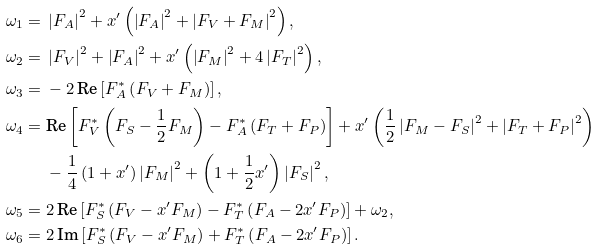Convert formula to latex. <formula><loc_0><loc_0><loc_500><loc_500>\omega _ { 1 } = & \ \left | F _ { A } \right | ^ { 2 } + x ^ { \prime } \left ( \left | F _ { A } \right | ^ { 2 } + \left | F _ { V } + F _ { M } \right | ^ { 2 } \right ) , \\ \omega _ { 2 } = & \ \left | F _ { V } \right | ^ { 2 } + \left | F _ { A } \right | ^ { 2 } + x ^ { \prime } \left ( \left | F _ { M } \right | ^ { 2 } + 4 \left | F _ { T } \right | ^ { 2 } \right ) , \\ \omega _ { 3 } = & \ - 2 \, \text {Re} \left [ F _ { A } ^ { * } \left ( F _ { V } + F _ { M } \right ) \right ] , \\ \omega _ { 4 } = & \ \text {Re} \left [ F _ { V } ^ { * } \left ( F _ { S } - \frac { 1 } { 2 } F _ { M } \right ) - F _ { A } ^ { * } \left ( F _ { T } + F _ { P } \right ) \right ] + x ^ { \prime } \left ( \frac { 1 } { 2 } \left | F _ { M } - F _ { S } \right | ^ { 2 } + \left | F _ { T } + F _ { P } \right | ^ { 2 } \right ) \\ & \ - \frac { 1 } { 4 } \left ( 1 + x ^ { \prime } \right ) \left | F _ { M } \right | ^ { 2 } + \left ( 1 + \frac { 1 } { 2 } x ^ { \prime } \right ) \left | F _ { S } \right | ^ { 2 } , \\ \omega _ { 5 } = & \ 2 \, \text {Re} \left [ F _ { S } ^ { * } \left ( F _ { V } - x ^ { \prime } F _ { M } \right ) - F _ { T } ^ { * } \left ( F _ { A } - 2 x ^ { \prime } F _ { P } \right ) \right ] + \omega _ { 2 } , \\ \omega _ { 6 } = & \ 2 \, \text {Im} \left [ F _ { S } ^ { * } \left ( F _ { V } - x ^ { \prime } F _ { M } \right ) + F _ { T } ^ { * } \left ( F _ { A } - 2 x ^ { \prime } F _ { P } \right ) \right ] .</formula> 